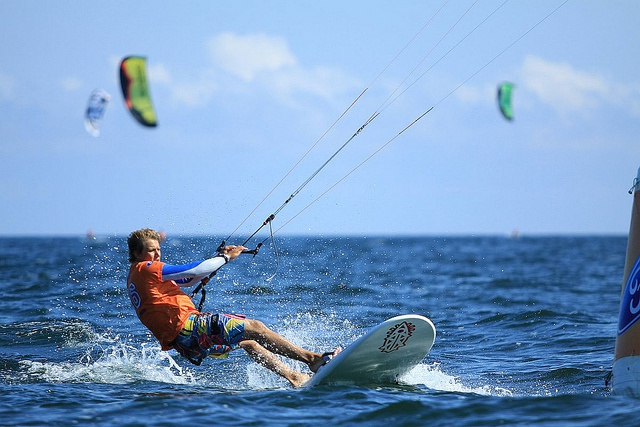Describe the objects in this image and their specific colors. I can see people in lightblue, black, maroon, gray, and navy tones, surfboard in lightblue, teal, black, and gray tones, kite in lightblue, olive, green, black, and gray tones, kite in lightblue, gray, and lavender tones, and kite in lightblue and turquoise tones in this image. 